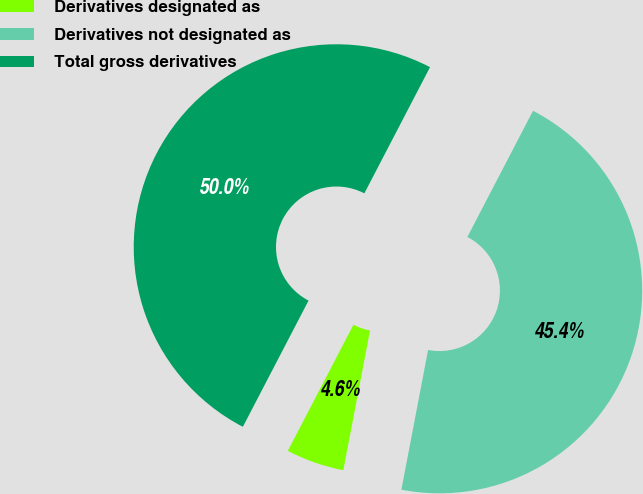Convert chart to OTSL. <chart><loc_0><loc_0><loc_500><loc_500><pie_chart><fcel>Derivatives designated as<fcel>Derivatives not designated as<fcel>Total gross derivatives<nl><fcel>4.63%<fcel>45.37%<fcel>50.0%<nl></chart> 